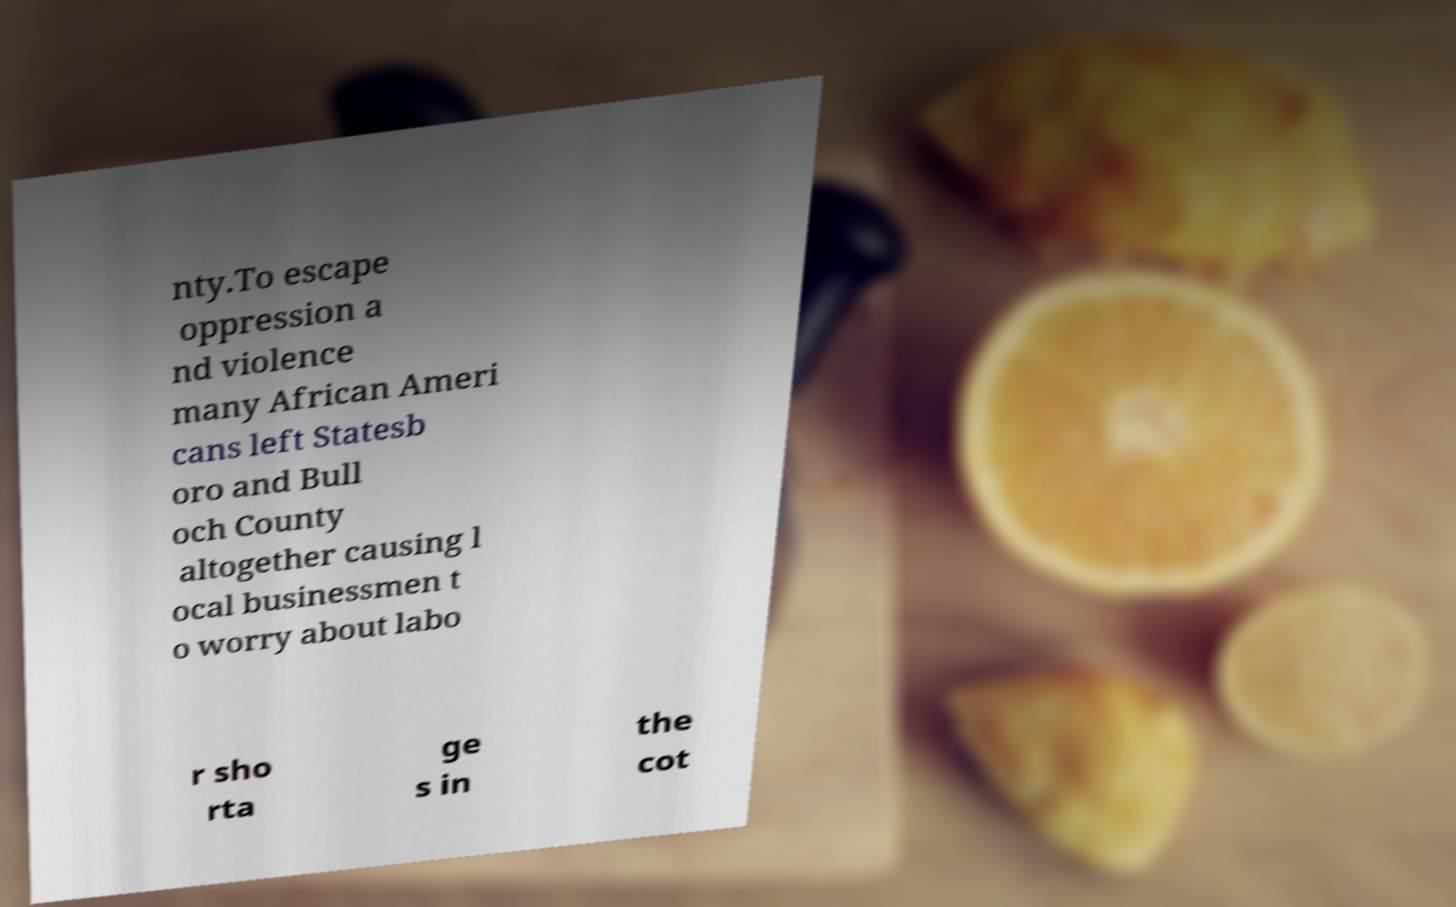Can you read and provide the text displayed in the image?This photo seems to have some interesting text. Can you extract and type it out for me? nty.To escape oppression a nd violence many African Ameri cans left Statesb oro and Bull och County altogether causing l ocal businessmen t o worry about labo r sho rta ge s in the cot 